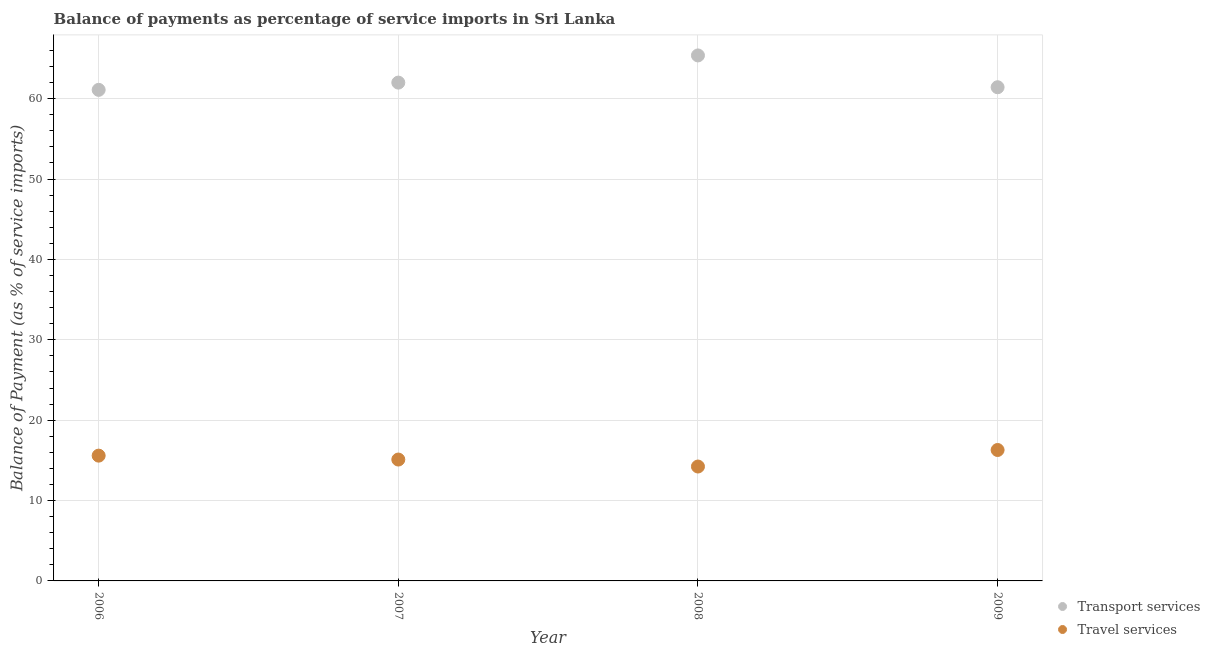How many different coloured dotlines are there?
Keep it short and to the point. 2. Is the number of dotlines equal to the number of legend labels?
Your answer should be compact. Yes. What is the balance of payments of travel services in 2007?
Offer a very short reply. 15.1. Across all years, what is the maximum balance of payments of travel services?
Give a very brief answer. 16.29. Across all years, what is the minimum balance of payments of transport services?
Give a very brief answer. 61.1. What is the total balance of payments of travel services in the graph?
Your answer should be compact. 61.21. What is the difference between the balance of payments of travel services in 2006 and that in 2009?
Give a very brief answer. -0.7. What is the difference between the balance of payments of transport services in 2007 and the balance of payments of travel services in 2008?
Give a very brief answer. 47.77. What is the average balance of payments of transport services per year?
Provide a succinct answer. 62.48. In the year 2008, what is the difference between the balance of payments of travel services and balance of payments of transport services?
Offer a terse response. -51.15. What is the ratio of the balance of payments of transport services in 2007 to that in 2009?
Offer a very short reply. 1.01. Is the balance of payments of travel services in 2007 less than that in 2008?
Your answer should be very brief. No. Is the difference between the balance of payments of travel services in 2006 and 2008 greater than the difference between the balance of payments of transport services in 2006 and 2008?
Provide a succinct answer. Yes. What is the difference between the highest and the second highest balance of payments of transport services?
Provide a short and direct response. 3.38. What is the difference between the highest and the lowest balance of payments of transport services?
Make the answer very short. 4.28. In how many years, is the balance of payments of transport services greater than the average balance of payments of transport services taken over all years?
Your answer should be very brief. 1. Does the balance of payments of travel services monotonically increase over the years?
Make the answer very short. No. Is the balance of payments of travel services strictly less than the balance of payments of transport services over the years?
Offer a very short reply. Yes. How many dotlines are there?
Offer a very short reply. 2. Does the graph contain grids?
Your answer should be very brief. Yes. What is the title of the graph?
Make the answer very short. Balance of payments as percentage of service imports in Sri Lanka. What is the label or title of the Y-axis?
Provide a short and direct response. Balance of Payment (as % of service imports). What is the Balance of Payment (as % of service imports) of Transport services in 2006?
Ensure brevity in your answer.  61.1. What is the Balance of Payment (as % of service imports) of Travel services in 2006?
Ensure brevity in your answer.  15.59. What is the Balance of Payment (as % of service imports) in Travel services in 2007?
Offer a terse response. 15.1. What is the Balance of Payment (as % of service imports) of Transport services in 2008?
Make the answer very short. 65.38. What is the Balance of Payment (as % of service imports) of Travel services in 2008?
Give a very brief answer. 14.23. What is the Balance of Payment (as % of service imports) in Transport services in 2009?
Make the answer very short. 61.42. What is the Balance of Payment (as % of service imports) in Travel services in 2009?
Offer a terse response. 16.29. Across all years, what is the maximum Balance of Payment (as % of service imports) in Transport services?
Your answer should be compact. 65.38. Across all years, what is the maximum Balance of Payment (as % of service imports) in Travel services?
Your response must be concise. 16.29. Across all years, what is the minimum Balance of Payment (as % of service imports) in Transport services?
Keep it short and to the point. 61.1. Across all years, what is the minimum Balance of Payment (as % of service imports) in Travel services?
Offer a terse response. 14.23. What is the total Balance of Payment (as % of service imports) of Transport services in the graph?
Keep it short and to the point. 249.9. What is the total Balance of Payment (as % of service imports) of Travel services in the graph?
Provide a succinct answer. 61.21. What is the difference between the Balance of Payment (as % of service imports) in Transport services in 2006 and that in 2007?
Your answer should be very brief. -0.9. What is the difference between the Balance of Payment (as % of service imports) of Travel services in 2006 and that in 2007?
Your answer should be compact. 0.49. What is the difference between the Balance of Payment (as % of service imports) in Transport services in 2006 and that in 2008?
Your answer should be compact. -4.28. What is the difference between the Balance of Payment (as % of service imports) of Travel services in 2006 and that in 2008?
Provide a succinct answer. 1.35. What is the difference between the Balance of Payment (as % of service imports) of Transport services in 2006 and that in 2009?
Provide a short and direct response. -0.33. What is the difference between the Balance of Payment (as % of service imports) of Travel services in 2006 and that in 2009?
Ensure brevity in your answer.  -0.7. What is the difference between the Balance of Payment (as % of service imports) of Transport services in 2007 and that in 2008?
Your answer should be very brief. -3.38. What is the difference between the Balance of Payment (as % of service imports) of Travel services in 2007 and that in 2008?
Provide a short and direct response. 0.87. What is the difference between the Balance of Payment (as % of service imports) of Transport services in 2007 and that in 2009?
Your answer should be very brief. 0.58. What is the difference between the Balance of Payment (as % of service imports) in Travel services in 2007 and that in 2009?
Give a very brief answer. -1.19. What is the difference between the Balance of Payment (as % of service imports) in Transport services in 2008 and that in 2009?
Keep it short and to the point. 3.96. What is the difference between the Balance of Payment (as % of service imports) of Travel services in 2008 and that in 2009?
Your response must be concise. -2.06. What is the difference between the Balance of Payment (as % of service imports) of Transport services in 2006 and the Balance of Payment (as % of service imports) of Travel services in 2007?
Give a very brief answer. 46. What is the difference between the Balance of Payment (as % of service imports) of Transport services in 2006 and the Balance of Payment (as % of service imports) of Travel services in 2008?
Keep it short and to the point. 46.87. What is the difference between the Balance of Payment (as % of service imports) of Transport services in 2006 and the Balance of Payment (as % of service imports) of Travel services in 2009?
Ensure brevity in your answer.  44.81. What is the difference between the Balance of Payment (as % of service imports) in Transport services in 2007 and the Balance of Payment (as % of service imports) in Travel services in 2008?
Offer a terse response. 47.77. What is the difference between the Balance of Payment (as % of service imports) in Transport services in 2007 and the Balance of Payment (as % of service imports) in Travel services in 2009?
Offer a very short reply. 45.71. What is the difference between the Balance of Payment (as % of service imports) of Transport services in 2008 and the Balance of Payment (as % of service imports) of Travel services in 2009?
Ensure brevity in your answer.  49.09. What is the average Balance of Payment (as % of service imports) in Transport services per year?
Your answer should be compact. 62.48. What is the average Balance of Payment (as % of service imports) of Travel services per year?
Your response must be concise. 15.3. In the year 2006, what is the difference between the Balance of Payment (as % of service imports) in Transport services and Balance of Payment (as % of service imports) in Travel services?
Keep it short and to the point. 45.51. In the year 2007, what is the difference between the Balance of Payment (as % of service imports) of Transport services and Balance of Payment (as % of service imports) of Travel services?
Your answer should be very brief. 46.9. In the year 2008, what is the difference between the Balance of Payment (as % of service imports) in Transport services and Balance of Payment (as % of service imports) in Travel services?
Keep it short and to the point. 51.15. In the year 2009, what is the difference between the Balance of Payment (as % of service imports) in Transport services and Balance of Payment (as % of service imports) in Travel services?
Provide a short and direct response. 45.13. What is the ratio of the Balance of Payment (as % of service imports) in Transport services in 2006 to that in 2007?
Ensure brevity in your answer.  0.99. What is the ratio of the Balance of Payment (as % of service imports) of Travel services in 2006 to that in 2007?
Offer a very short reply. 1.03. What is the ratio of the Balance of Payment (as % of service imports) of Transport services in 2006 to that in 2008?
Keep it short and to the point. 0.93. What is the ratio of the Balance of Payment (as % of service imports) of Travel services in 2006 to that in 2008?
Offer a terse response. 1.1. What is the ratio of the Balance of Payment (as % of service imports) of Transport services in 2006 to that in 2009?
Offer a terse response. 0.99. What is the ratio of the Balance of Payment (as % of service imports) in Travel services in 2006 to that in 2009?
Make the answer very short. 0.96. What is the ratio of the Balance of Payment (as % of service imports) of Transport services in 2007 to that in 2008?
Ensure brevity in your answer.  0.95. What is the ratio of the Balance of Payment (as % of service imports) in Travel services in 2007 to that in 2008?
Your answer should be compact. 1.06. What is the ratio of the Balance of Payment (as % of service imports) of Transport services in 2007 to that in 2009?
Your answer should be very brief. 1.01. What is the ratio of the Balance of Payment (as % of service imports) of Travel services in 2007 to that in 2009?
Give a very brief answer. 0.93. What is the ratio of the Balance of Payment (as % of service imports) in Transport services in 2008 to that in 2009?
Ensure brevity in your answer.  1.06. What is the ratio of the Balance of Payment (as % of service imports) of Travel services in 2008 to that in 2009?
Give a very brief answer. 0.87. What is the difference between the highest and the second highest Balance of Payment (as % of service imports) in Transport services?
Keep it short and to the point. 3.38. What is the difference between the highest and the second highest Balance of Payment (as % of service imports) of Travel services?
Your answer should be compact. 0.7. What is the difference between the highest and the lowest Balance of Payment (as % of service imports) in Transport services?
Your answer should be compact. 4.28. What is the difference between the highest and the lowest Balance of Payment (as % of service imports) of Travel services?
Offer a very short reply. 2.06. 